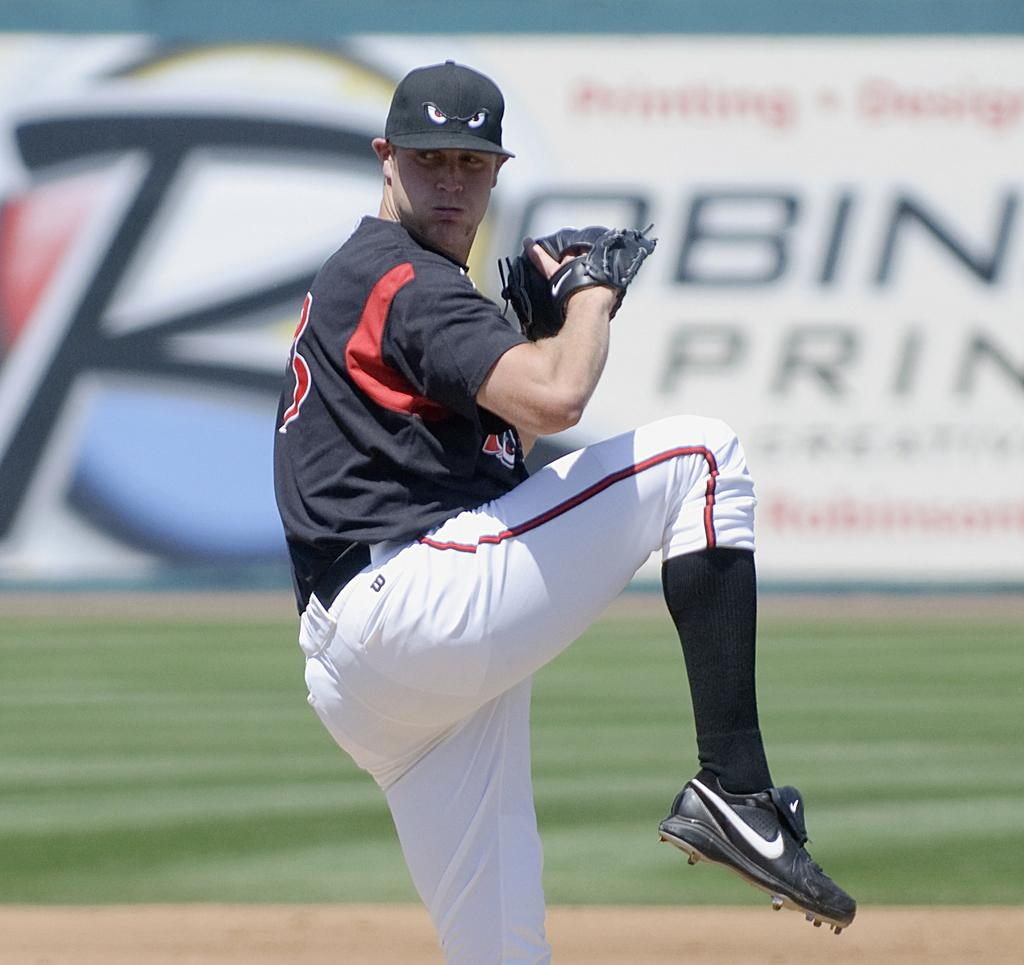<image>
Render a clear and concise summary of the photo. A pitcher is going through his windup and a Robin ad is seen in the background. 